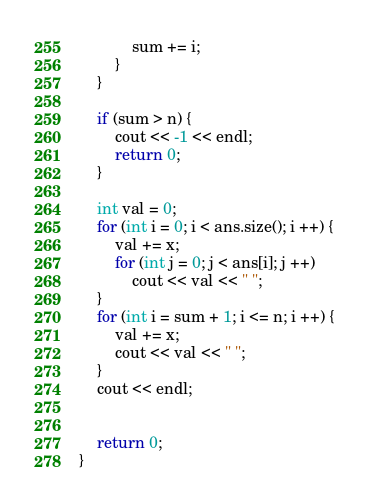<code> <loc_0><loc_0><loc_500><loc_500><_C++_>			sum += i;
		}
	}

	if (sum > n) {
		cout << -1 << endl;
		return 0;
	}

	int val = 0;
	for (int i = 0; i < ans.size(); i ++) {
		val += x;
		for (int j = 0; j < ans[i]; j ++)
			cout << val << " ";
	}
	for (int i = sum + 1; i <= n; i ++) {
		val += x;
		cout << val << " ";
	}
	cout << endl;
	

	return 0;
}	</code> 